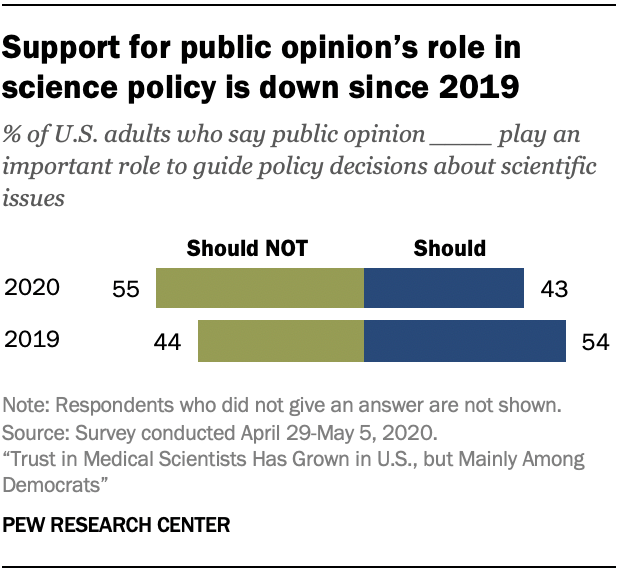Highlight a few significant elements in this photo. The sum of all the bars in 2020 is equal to the sum of all the bars in 2019. According to a survey conducted in 2019, 54% of adults in the United States believe that public opinion should play a significant role in guiding policy decisions regarding scientific issues. 